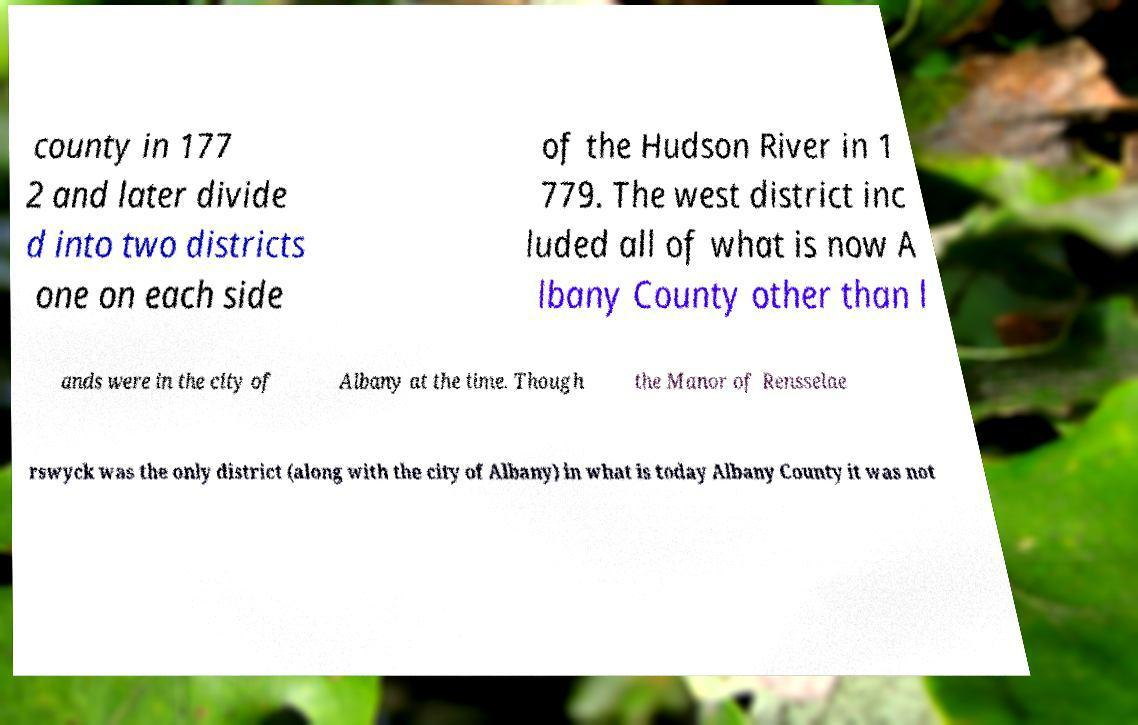What messages or text are displayed in this image? I need them in a readable, typed format. county in 177 2 and later divide d into two districts one on each side of the Hudson River in 1 779. The west district inc luded all of what is now A lbany County other than l ands were in the city of Albany at the time. Though the Manor of Rensselae rswyck was the only district (along with the city of Albany) in what is today Albany County it was not 